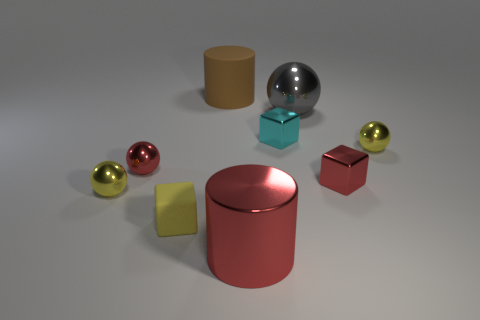How many other objects are there of the same material as the big ball?
Provide a short and direct response. 6. Are there an equal number of shiny cylinders behind the small yellow rubber cube and red metallic objects behind the cyan metallic thing?
Ensure brevity in your answer.  Yes. What is the color of the cylinder that is in front of the tiny yellow metallic sphere on the left side of the cylinder behind the tiny red metallic cube?
Keep it short and to the point. Red. There is a tiny yellow thing to the right of the cyan thing; what shape is it?
Ensure brevity in your answer.  Sphere. There is a small cyan thing that is the same material as the red ball; what is its shape?
Provide a short and direct response. Cube. Are there any other things that are the same shape as the brown object?
Your response must be concise. Yes. What number of large gray spheres are left of the big red shiny object?
Your answer should be very brief. 0. Is the number of small yellow matte objects behind the large metal sphere the same as the number of spheres?
Provide a succinct answer. No. Is the red cylinder made of the same material as the tiny cyan block?
Keep it short and to the point. Yes. There is a cube that is in front of the cyan metallic cube and behind the yellow matte block; what is its size?
Your answer should be very brief. Small. 